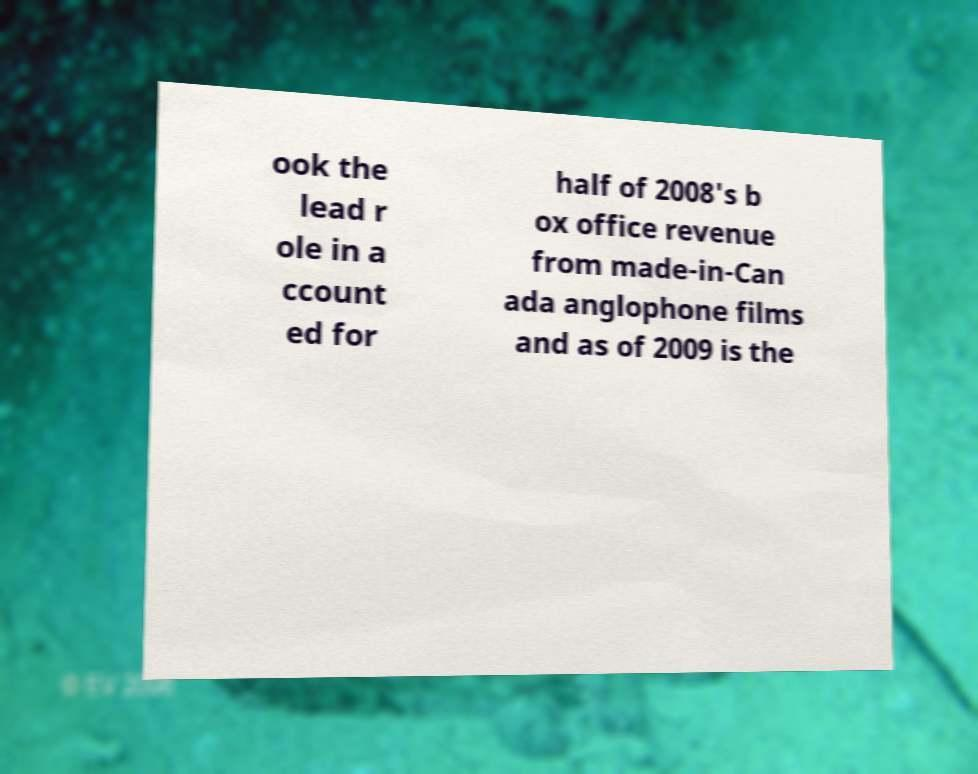What messages or text are displayed in this image? I need them in a readable, typed format. ook the lead r ole in a ccount ed for half of 2008's b ox office revenue from made-in-Can ada anglophone films and as of 2009 is the 